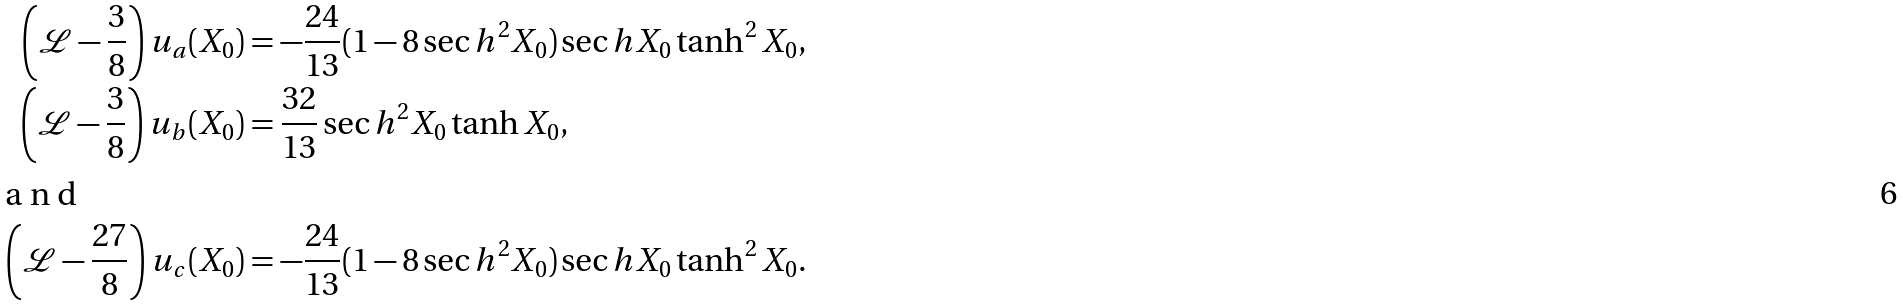<formula> <loc_0><loc_0><loc_500><loc_500>\left ( { \mathcal { L } } - \frac { 3 } { 8 } \right ) u _ { a } ( X _ { 0 } ) & = - \frac { 2 4 } { 1 3 } ( 1 - 8 \sec h ^ { 2 } X _ { 0 } ) \sec h X _ { 0 } \tanh ^ { 2 } X _ { 0 } , \\ \left ( { \mathcal { L } } - \frac { 3 } { 8 } \right ) u _ { b } ( X _ { 0 } ) & = \frac { 3 2 } { 1 3 } \sec h ^ { 2 } X _ { 0 } \tanh X _ { 0 } , \intertext { a n d } \left ( { \mathcal { L } } - \frac { 2 7 } { 8 } \right ) u _ { c } ( X _ { 0 } ) & = - \frac { 2 4 } { 1 3 } ( 1 - 8 \sec h ^ { 2 } X _ { 0 } ) \sec h X _ { 0 } \tanh ^ { 2 } X _ { 0 } .</formula> 